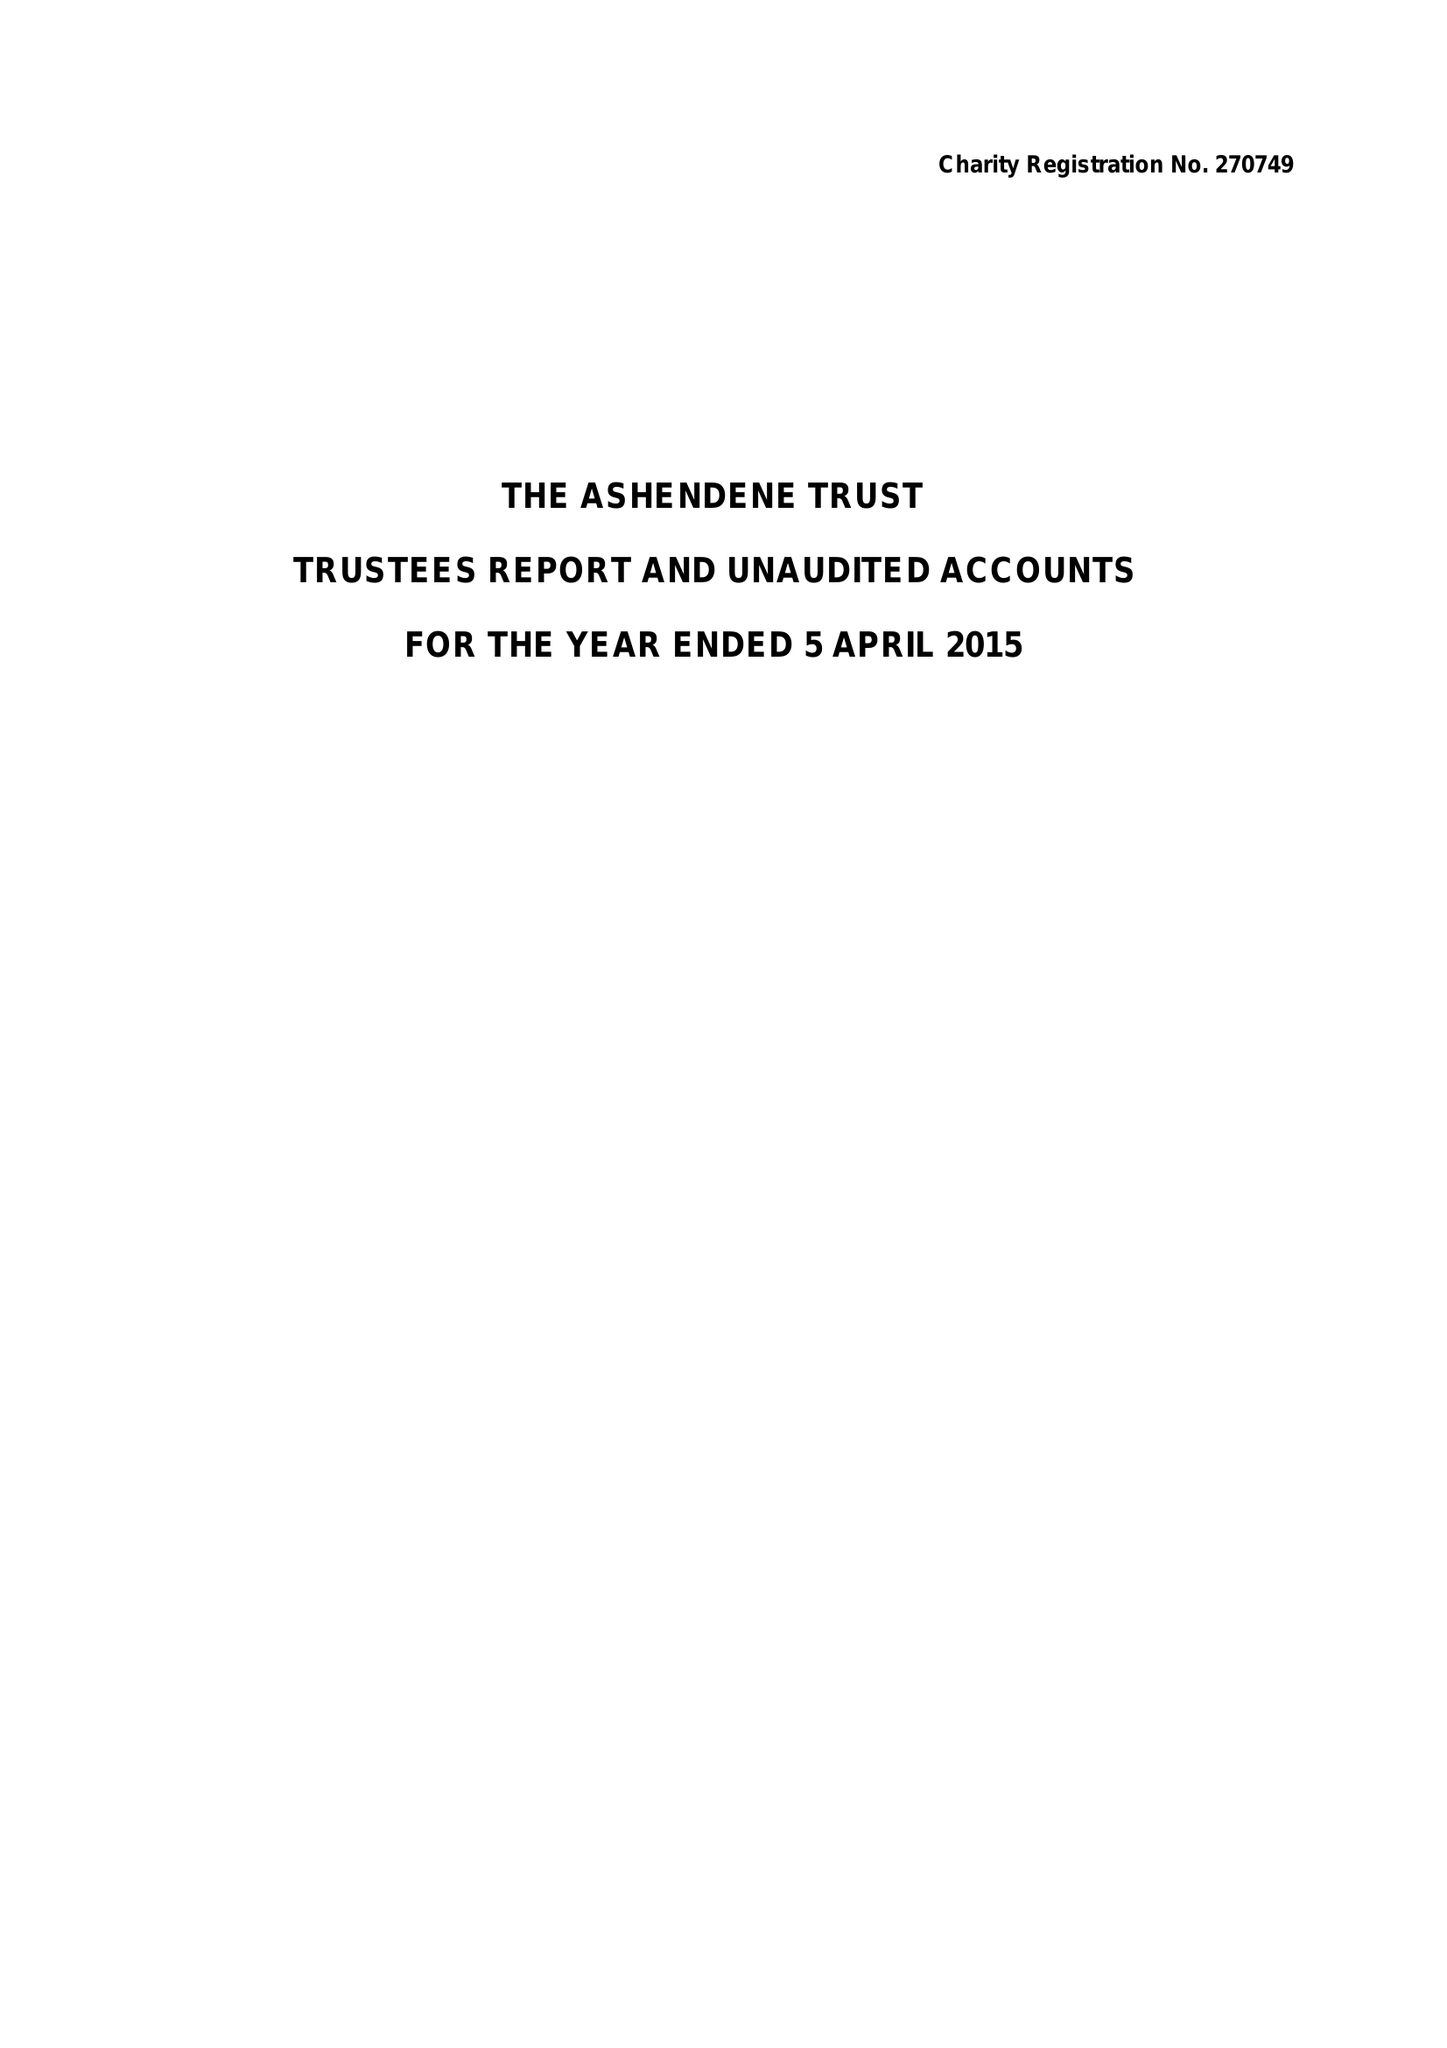What is the value for the charity_name?
Answer the question using a single word or phrase. Ashendene Trust 